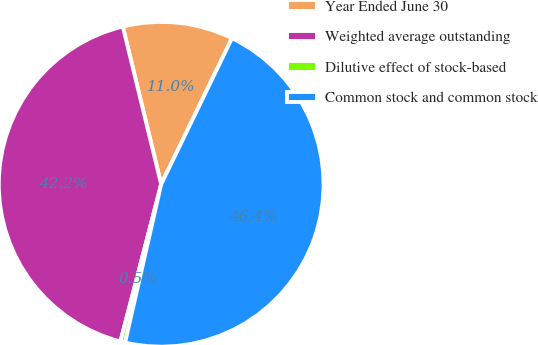Convert chart. <chart><loc_0><loc_0><loc_500><loc_500><pie_chart><fcel>Year Ended June 30<fcel>Weighted average outstanding<fcel>Dilutive effect of stock-based<fcel>Common stock and common stock<nl><fcel>10.98%<fcel>42.17%<fcel>0.47%<fcel>46.38%<nl></chart> 